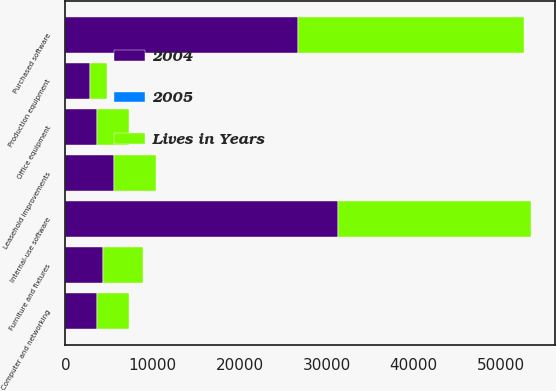<chart> <loc_0><loc_0><loc_500><loc_500><stacked_bar_chart><ecel><fcel>Computer and networking<fcel>Purchased software<fcel>Furniture and fixtures<fcel>Office equipment<fcel>Leasehold improvements<fcel>Production equipment<fcel>Internal-use software<nl><fcel>2004<fcel>3664<fcel>26695<fcel>4355<fcel>3664<fcel>5569<fcel>2839<fcel>31371<nl><fcel>Lives in Years<fcel>3664<fcel>25941<fcel>4612<fcel>3690<fcel>4832<fcel>1928<fcel>22158<nl><fcel>2005<fcel>3<fcel>3<fcel>5<fcel>3<fcel>57<fcel>3<fcel>2<nl></chart> 